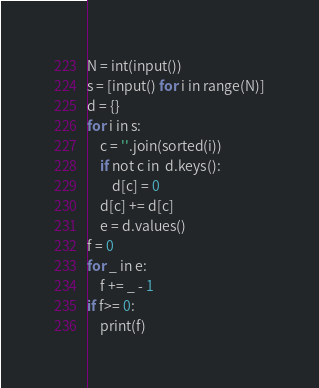<code> <loc_0><loc_0><loc_500><loc_500><_Python_>N = int(input())
s = [input() for i in range(N)]
d = {}
for i in s:
    c = ''.join(sorted(i))
    if not c in  d.keys():
        d[c] = 0
    d[c] += d[c]
    e = d.values()
f = 0
for _ in e:
    f += _ - 1
if f>= 0:
    print(f)</code> 